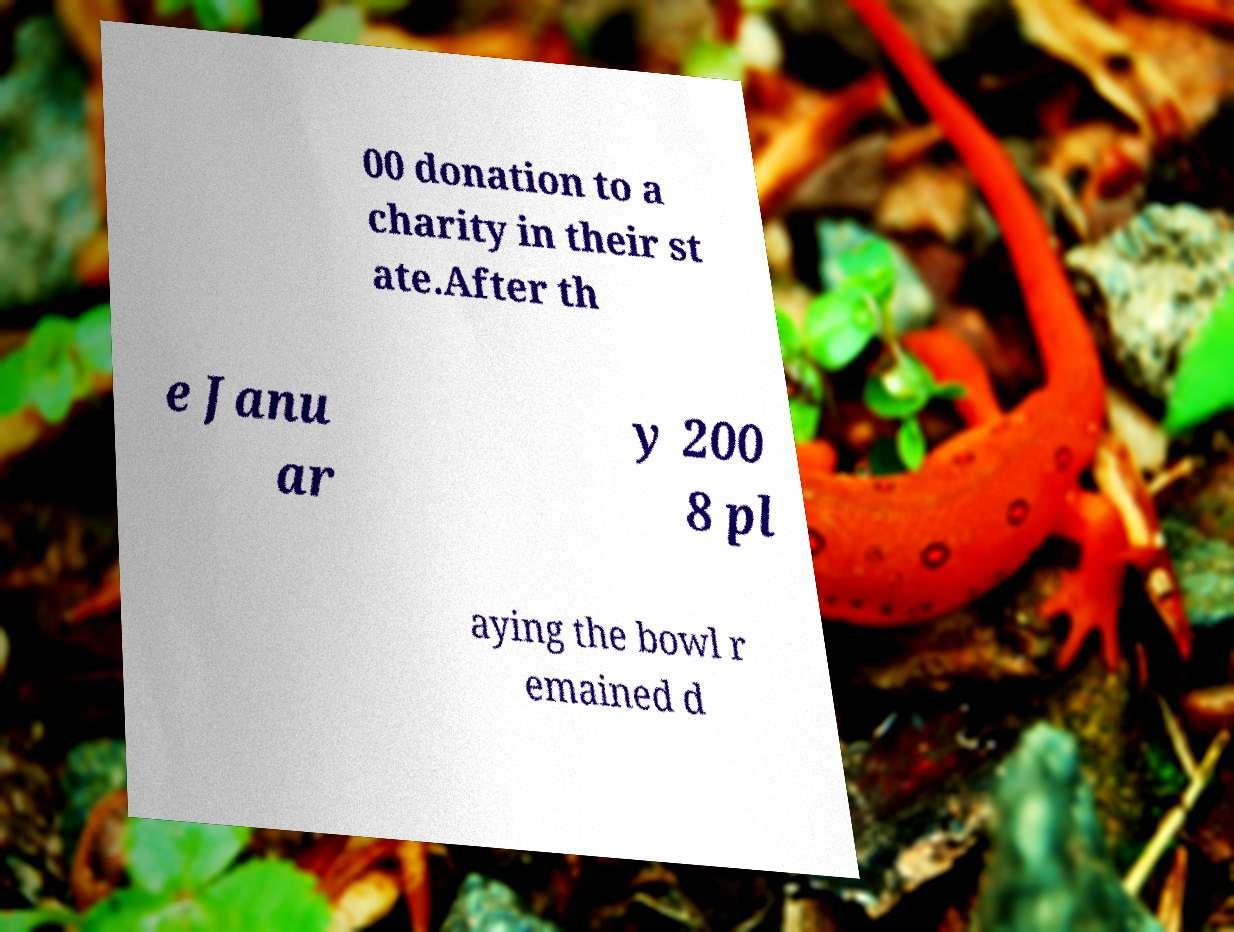What messages or text are displayed in this image? I need them in a readable, typed format. 00 donation to a charity in their st ate.After th e Janu ar y 200 8 pl aying the bowl r emained d 